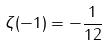Convert formula to latex. <formula><loc_0><loc_0><loc_500><loc_500>\zeta ( - 1 ) = - \frac { 1 } { 1 2 }</formula> 